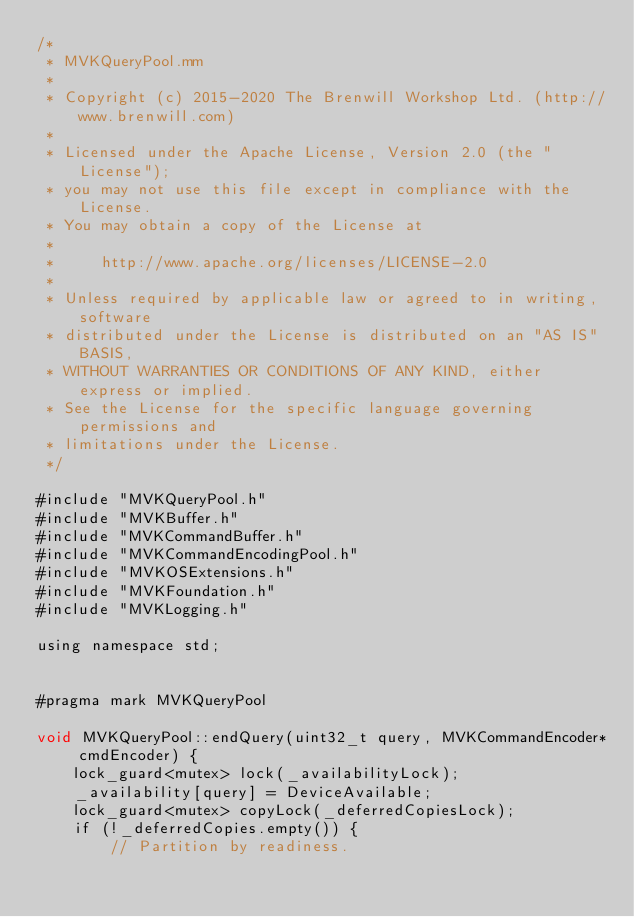Convert code to text. <code><loc_0><loc_0><loc_500><loc_500><_ObjectiveC_>/*
 * MVKQueryPool.mm
 *
 * Copyright (c) 2015-2020 The Brenwill Workshop Ltd. (http://www.brenwill.com)
 *
 * Licensed under the Apache License, Version 2.0 (the "License");
 * you may not use this file except in compliance with the License.
 * You may obtain a copy of the License at
 * 
 *     http://www.apache.org/licenses/LICENSE-2.0
 * 
 * Unless required by applicable law or agreed to in writing, software
 * distributed under the License is distributed on an "AS IS" BASIS,
 * WITHOUT WARRANTIES OR CONDITIONS OF ANY KIND, either express or implied.
 * See the License for the specific language governing permissions and
 * limitations under the License.
 */

#include "MVKQueryPool.h"
#include "MVKBuffer.h"
#include "MVKCommandBuffer.h"
#include "MVKCommandEncodingPool.h"
#include "MVKOSExtensions.h"
#include "MVKFoundation.h"
#include "MVKLogging.h"

using namespace std;


#pragma mark MVKQueryPool

void MVKQueryPool::endQuery(uint32_t query, MVKCommandEncoder* cmdEncoder) {
    lock_guard<mutex> lock(_availabilityLock);
    _availability[query] = DeviceAvailable;
    lock_guard<mutex> copyLock(_deferredCopiesLock);
    if (!_deferredCopies.empty()) {
        // Partition by readiness.</code> 